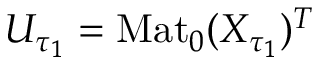Convert formula to latex. <formula><loc_0><loc_0><loc_500><loc_500>U _ { \tau _ { 1 } } = M a t _ { 0 } ( X _ { \tau _ { 1 } } ) ^ { T }</formula> 